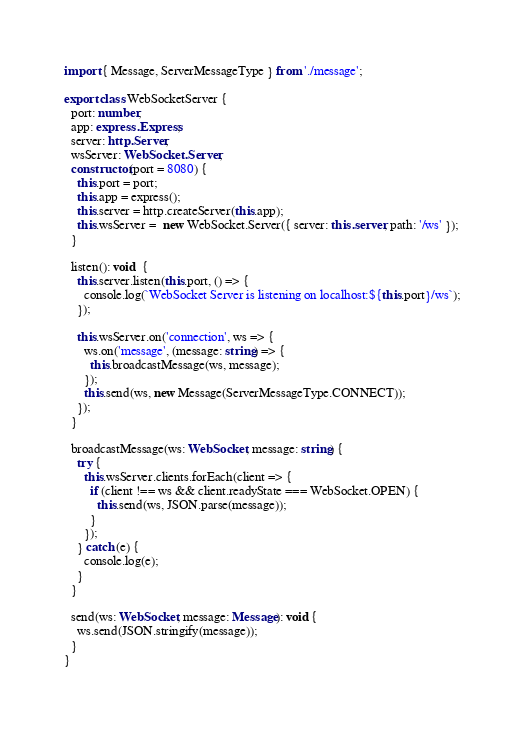<code> <loc_0><loc_0><loc_500><loc_500><_TypeScript_>import { Message, ServerMessageType } from './message';

export class WebSocketServer {
  port: number;
  app: express.Express;
  server: http.Server;
  wsServer: WebSocket.Server;
  constructor(port = 8080) {
    this.port = port;
    this.app = express();
    this.server = http.createServer(this.app);
    this.wsServer =  new WebSocket.Server({ server: this.server, path: '/ws' });
  }

  listen(): void  {
    this.server.listen(this.port, () => {
      console.log(`WebSocket Server is listening on localhost:${this.port}/ws`);
    });

    this.wsServer.on('connection', ws => {
      ws.on('message', (message: string) => {
        this.broadcastMessage(ws, message);
      });
      this.send(ws, new Message(ServerMessageType.CONNECT));
    });
  }

  broadcastMessage(ws: WebSocket, message: string) {
    try {
      this.wsServer.clients.forEach(client => {
        if (client !== ws && client.readyState === WebSocket.OPEN) {
          this.send(ws, JSON.parse(message));
        }
      });
    } catch (e) {
      console.log(e);
    }
  }

  send(ws: WebSocket, message: Message): void {
    ws.send(JSON.stringify(message));
  }
}
</code> 